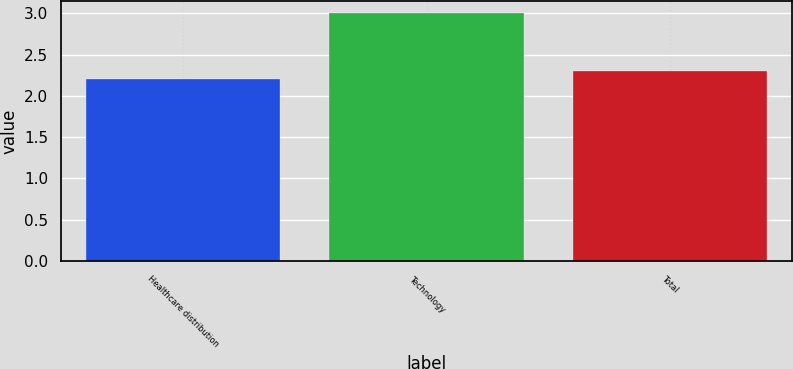Convert chart. <chart><loc_0><loc_0><loc_500><loc_500><bar_chart><fcel>Healthcare distribution<fcel>Technology<fcel>Total<nl><fcel>2.2<fcel>3<fcel>2.3<nl></chart> 